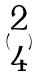<formula> <loc_0><loc_0><loc_500><loc_500>( \begin{matrix} 2 \\ 4 \end{matrix} )</formula> 